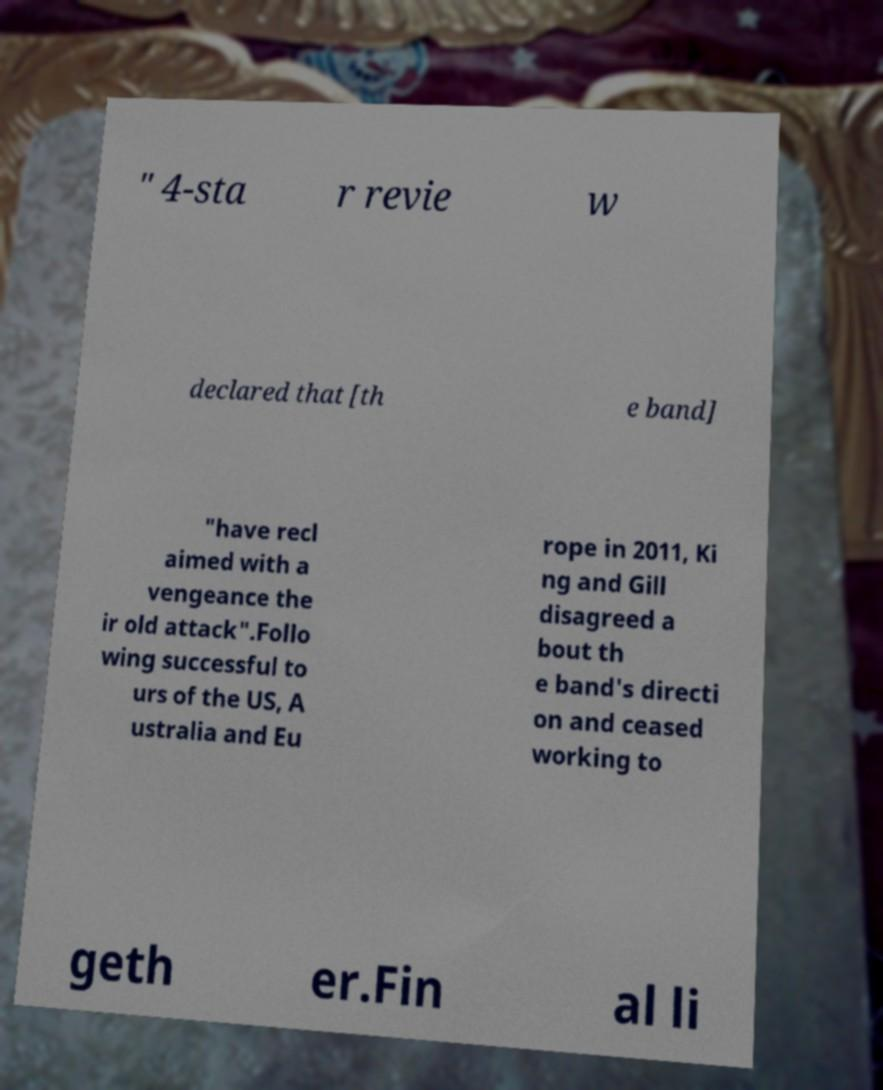Can you accurately transcribe the text from the provided image for me? " 4-sta r revie w declared that [th e band] "have recl aimed with a vengeance the ir old attack".Follo wing successful to urs of the US, A ustralia and Eu rope in 2011, Ki ng and Gill disagreed a bout th e band's directi on and ceased working to geth er.Fin al li 